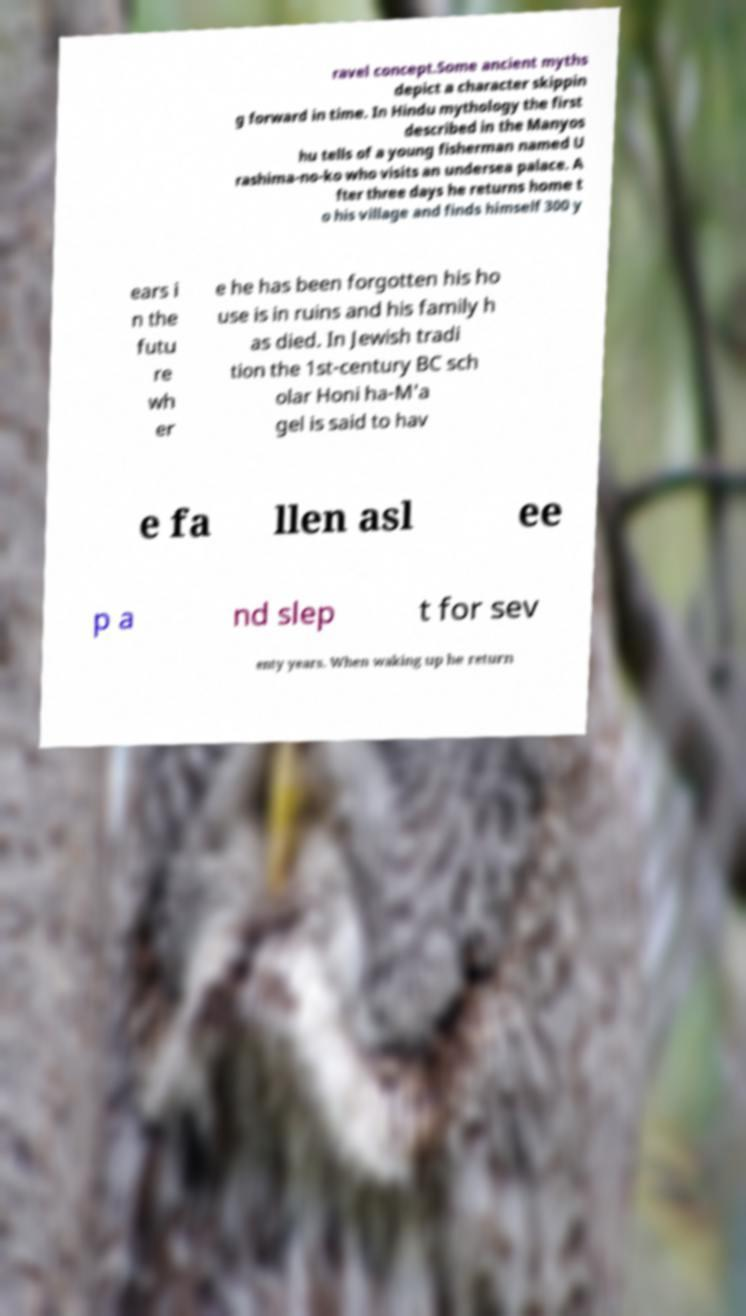I need the written content from this picture converted into text. Can you do that? ravel concept.Some ancient myths depict a character skippin g forward in time. In Hindu mythology the first described in the Manyos hu tells of a young fisherman named U rashima-no-ko who visits an undersea palace. A fter three days he returns home t o his village and finds himself 300 y ears i n the futu re wh er e he has been forgotten his ho use is in ruins and his family h as died. In Jewish tradi tion the 1st-century BC sch olar Honi ha-M'a gel is said to hav e fa llen asl ee p a nd slep t for sev enty years. When waking up he return 